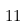Convert formula to latex. <formula><loc_0><loc_0><loc_500><loc_500>1 1</formula> 